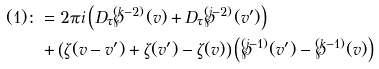<formula> <loc_0><loc_0><loc_500><loc_500>( 1 ) \colon & = 2 \pi i \left ( D _ { \tau } \wp ^ { ( k - 2 ) } ( v ) + D _ { \tau } \wp ^ { ( j - 2 ) } ( v ^ { \prime } ) \right ) \\ & + \left ( \zeta ( v - v ^ { \prime } ) + \zeta ( v ^ { \prime } ) - \zeta ( v ) \right ) \left ( \wp ^ { ( j - 1 ) } ( v ^ { \prime } ) - \wp ^ { ( k - 1 ) } ( v ) \right )</formula> 